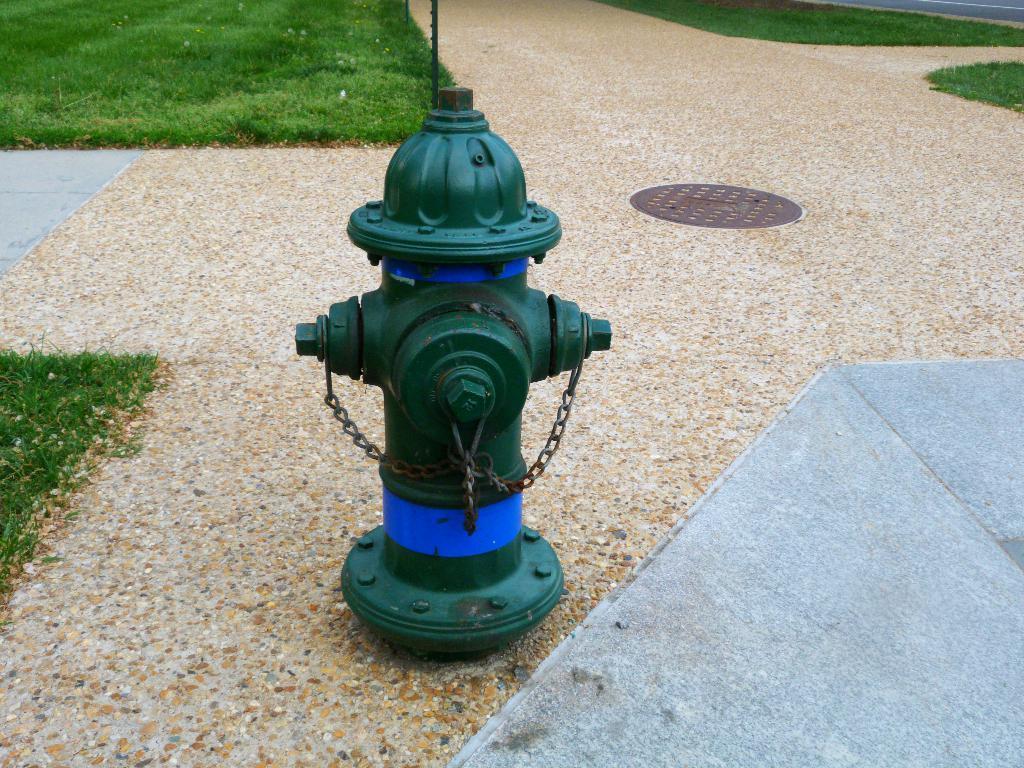Could you give a brief overview of what you see in this image? In this image we can see the fire hydrant on the ground. And we can see the grass and pole. Right side, it looks like a road. 